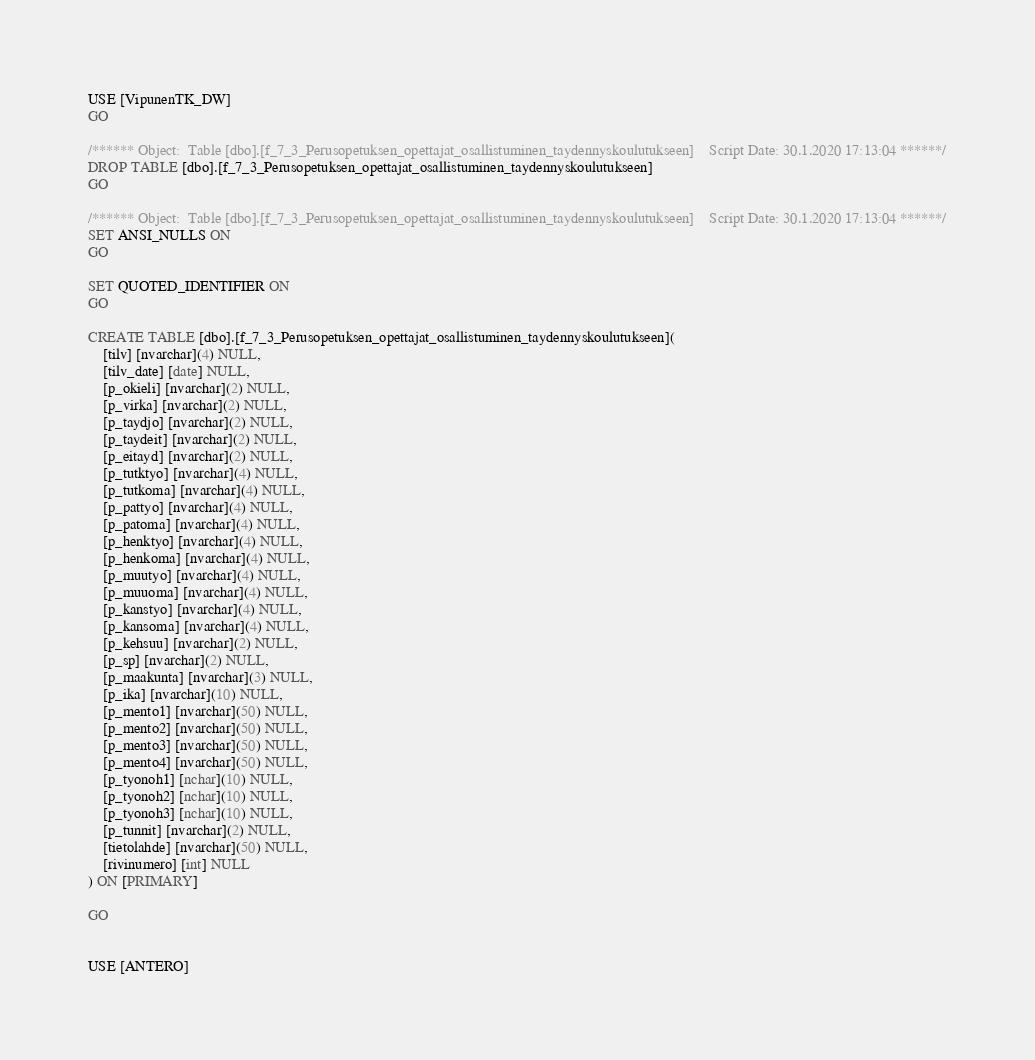<code> <loc_0><loc_0><loc_500><loc_500><_SQL_>USE [VipunenTK_DW]
GO

/****** Object:  Table [dbo].[f_7_3_Perusopetuksen_opettajat_osallistuminen_taydennyskoulutukseen]    Script Date: 30.1.2020 17:13:04 ******/
DROP TABLE [dbo].[f_7_3_Perusopetuksen_opettajat_osallistuminen_taydennyskoulutukseen]
GO

/****** Object:  Table [dbo].[f_7_3_Perusopetuksen_opettajat_osallistuminen_taydennyskoulutukseen]    Script Date: 30.1.2020 17:13:04 ******/
SET ANSI_NULLS ON
GO

SET QUOTED_IDENTIFIER ON
GO

CREATE TABLE [dbo].[f_7_3_Perusopetuksen_opettajat_osallistuminen_taydennyskoulutukseen](
	[tilv] [nvarchar](4) NULL,
	[tilv_date] [date] NULL,
	[p_okieli] [nvarchar](2) NULL,
	[p_virka] [nvarchar](2) NULL,
	[p_taydjo] [nvarchar](2) NULL,
	[p_taydeit] [nvarchar](2) NULL,
	[p_eitayd] [nvarchar](2) NULL,
	[p_tutktyo] [nvarchar](4) NULL,
	[p_tutkoma] [nvarchar](4) NULL,
	[p_pattyo] [nvarchar](4) NULL,
	[p_patoma] [nvarchar](4) NULL,
	[p_henktyo] [nvarchar](4) NULL,
	[p_henkoma] [nvarchar](4) NULL,
	[p_muutyo] [nvarchar](4) NULL,
	[p_muuoma] [nvarchar](4) NULL,
	[p_kanstyo] [nvarchar](4) NULL,
	[p_kansoma] [nvarchar](4) NULL,
	[p_kehsuu] [nvarchar](2) NULL,
	[p_sp] [nvarchar](2) NULL,
	[p_maakunta] [nvarchar](3) NULL,
	[p_ika] [nvarchar](10) NULL,
	[p_mento1] [nvarchar](50) NULL,
	[p_mento2] [nvarchar](50) NULL,
	[p_mento3] [nvarchar](50) NULL,
	[p_mento4] [nvarchar](50) NULL,
	[p_tyonoh1] [nchar](10) NULL,
	[p_tyonoh2] [nchar](10) NULL,
	[p_tyonoh3] [nchar](10) NULL,
	[p_tunnit] [nvarchar](2) NULL,
	[tietolahde] [nvarchar](50) NULL,
	[rivinumero] [int] NULL
) ON [PRIMARY]

GO


USE [ANTERO]</code> 